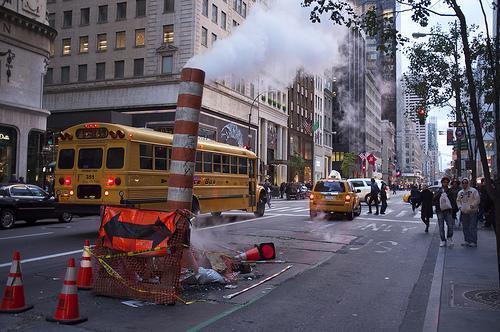How many buses are there?
Give a very brief answer. 1. 